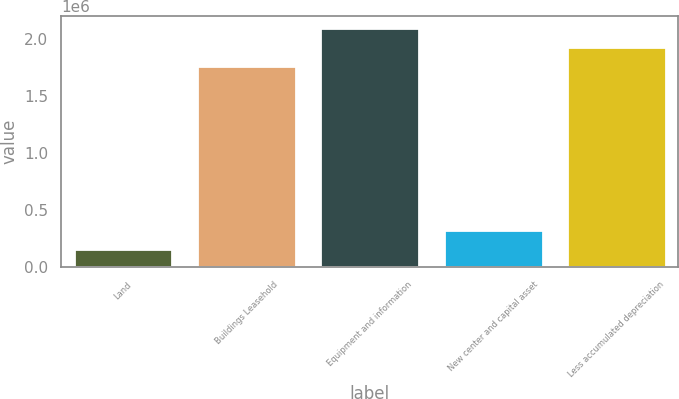Convert chart to OTSL. <chart><loc_0><loc_0><loc_500><loc_500><bar_chart><fcel>Land<fcel>Buildings Leasehold<fcel>Equipment and information<fcel>New center and capital asset<fcel>Less accumulated depreciation<nl><fcel>157998<fcel>1.76247e+06<fcel>2.09887e+06<fcel>326196<fcel>1.93067e+06<nl></chart> 